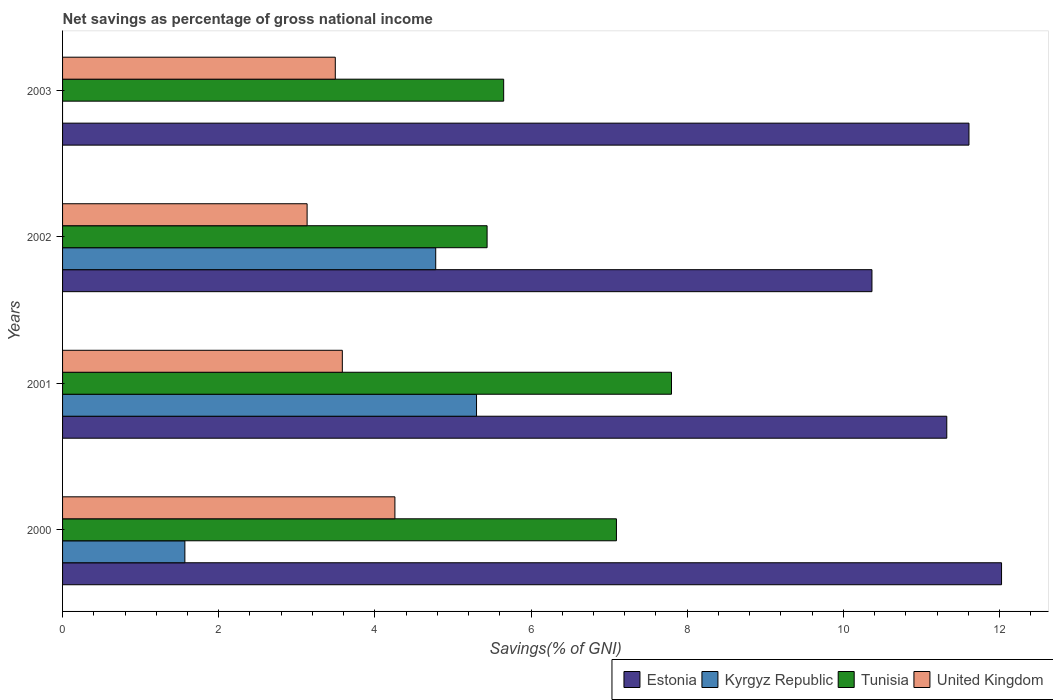How many groups of bars are there?
Give a very brief answer. 4. Are the number of bars on each tick of the Y-axis equal?
Provide a succinct answer. No. How many bars are there on the 4th tick from the top?
Provide a succinct answer. 4. What is the total savings in Estonia in 2000?
Provide a short and direct response. 12.03. Across all years, what is the maximum total savings in Tunisia?
Give a very brief answer. 7.8. Across all years, what is the minimum total savings in United Kingdom?
Provide a succinct answer. 3.13. What is the total total savings in Tunisia in the graph?
Make the answer very short. 25.98. What is the difference between the total savings in United Kingdom in 2001 and that in 2002?
Provide a short and direct response. 0.45. What is the difference between the total savings in United Kingdom in 2003 and the total savings in Kyrgyz Republic in 2002?
Offer a terse response. -1.29. What is the average total savings in United Kingdom per year?
Offer a very short reply. 3.62. In the year 2003, what is the difference between the total savings in Tunisia and total savings in United Kingdom?
Offer a very short reply. 2.16. What is the ratio of the total savings in Kyrgyz Republic in 2001 to that in 2002?
Your response must be concise. 1.11. What is the difference between the highest and the second highest total savings in Kyrgyz Republic?
Offer a very short reply. 0.52. What is the difference between the highest and the lowest total savings in Estonia?
Your answer should be very brief. 1.66. Is it the case that in every year, the sum of the total savings in Tunisia and total savings in United Kingdom is greater than the sum of total savings in Kyrgyz Republic and total savings in Estonia?
Give a very brief answer. Yes. How many bars are there?
Offer a terse response. 15. Are all the bars in the graph horizontal?
Your answer should be compact. Yes. How many years are there in the graph?
Keep it short and to the point. 4. What is the difference between two consecutive major ticks on the X-axis?
Make the answer very short. 2. Does the graph contain any zero values?
Keep it short and to the point. Yes. Does the graph contain grids?
Keep it short and to the point. No. What is the title of the graph?
Offer a terse response. Net savings as percentage of gross national income. Does "Bhutan" appear as one of the legend labels in the graph?
Provide a short and direct response. No. What is the label or title of the X-axis?
Make the answer very short. Savings(% of GNI). What is the label or title of the Y-axis?
Keep it short and to the point. Years. What is the Savings(% of GNI) of Estonia in 2000?
Provide a short and direct response. 12.03. What is the Savings(% of GNI) of Kyrgyz Republic in 2000?
Ensure brevity in your answer.  1.57. What is the Savings(% of GNI) of Tunisia in 2000?
Provide a short and direct response. 7.09. What is the Savings(% of GNI) of United Kingdom in 2000?
Your response must be concise. 4.26. What is the Savings(% of GNI) in Estonia in 2001?
Your answer should be compact. 11.33. What is the Savings(% of GNI) of Kyrgyz Republic in 2001?
Provide a succinct answer. 5.3. What is the Savings(% of GNI) in Tunisia in 2001?
Give a very brief answer. 7.8. What is the Savings(% of GNI) in United Kingdom in 2001?
Your answer should be compact. 3.58. What is the Savings(% of GNI) of Estonia in 2002?
Your answer should be very brief. 10.37. What is the Savings(% of GNI) in Kyrgyz Republic in 2002?
Offer a terse response. 4.78. What is the Savings(% of GNI) in Tunisia in 2002?
Your response must be concise. 5.44. What is the Savings(% of GNI) in United Kingdom in 2002?
Your answer should be compact. 3.13. What is the Savings(% of GNI) in Estonia in 2003?
Give a very brief answer. 11.61. What is the Savings(% of GNI) in Tunisia in 2003?
Offer a very short reply. 5.65. What is the Savings(% of GNI) in United Kingdom in 2003?
Your answer should be very brief. 3.49. Across all years, what is the maximum Savings(% of GNI) of Estonia?
Offer a very short reply. 12.03. Across all years, what is the maximum Savings(% of GNI) of Kyrgyz Republic?
Make the answer very short. 5.3. Across all years, what is the maximum Savings(% of GNI) of Tunisia?
Give a very brief answer. 7.8. Across all years, what is the maximum Savings(% of GNI) of United Kingdom?
Make the answer very short. 4.26. Across all years, what is the minimum Savings(% of GNI) in Estonia?
Give a very brief answer. 10.37. Across all years, what is the minimum Savings(% of GNI) in Tunisia?
Your answer should be very brief. 5.44. Across all years, what is the minimum Savings(% of GNI) of United Kingdom?
Your response must be concise. 3.13. What is the total Savings(% of GNI) of Estonia in the graph?
Your response must be concise. 45.33. What is the total Savings(% of GNI) in Kyrgyz Republic in the graph?
Your response must be concise. 11.65. What is the total Savings(% of GNI) of Tunisia in the graph?
Make the answer very short. 25.98. What is the total Savings(% of GNI) in United Kingdom in the graph?
Provide a succinct answer. 14.47. What is the difference between the Savings(% of GNI) in Estonia in 2000 and that in 2001?
Make the answer very short. 0.7. What is the difference between the Savings(% of GNI) of Kyrgyz Republic in 2000 and that in 2001?
Provide a succinct answer. -3.74. What is the difference between the Savings(% of GNI) of Tunisia in 2000 and that in 2001?
Keep it short and to the point. -0.71. What is the difference between the Savings(% of GNI) in United Kingdom in 2000 and that in 2001?
Ensure brevity in your answer.  0.67. What is the difference between the Savings(% of GNI) of Estonia in 2000 and that in 2002?
Keep it short and to the point. 1.66. What is the difference between the Savings(% of GNI) of Kyrgyz Republic in 2000 and that in 2002?
Offer a terse response. -3.21. What is the difference between the Savings(% of GNI) in Tunisia in 2000 and that in 2002?
Your answer should be very brief. 1.66. What is the difference between the Savings(% of GNI) in United Kingdom in 2000 and that in 2002?
Keep it short and to the point. 1.12. What is the difference between the Savings(% of GNI) of Estonia in 2000 and that in 2003?
Your answer should be compact. 0.42. What is the difference between the Savings(% of GNI) of Tunisia in 2000 and that in 2003?
Your answer should be compact. 1.44. What is the difference between the Savings(% of GNI) of United Kingdom in 2000 and that in 2003?
Give a very brief answer. 0.76. What is the difference between the Savings(% of GNI) in Estonia in 2001 and that in 2002?
Your answer should be very brief. 0.96. What is the difference between the Savings(% of GNI) of Kyrgyz Republic in 2001 and that in 2002?
Your response must be concise. 0.52. What is the difference between the Savings(% of GNI) in Tunisia in 2001 and that in 2002?
Your answer should be very brief. 2.36. What is the difference between the Savings(% of GNI) of United Kingdom in 2001 and that in 2002?
Your answer should be very brief. 0.45. What is the difference between the Savings(% of GNI) in Estonia in 2001 and that in 2003?
Your response must be concise. -0.28. What is the difference between the Savings(% of GNI) in Tunisia in 2001 and that in 2003?
Provide a short and direct response. 2.15. What is the difference between the Savings(% of GNI) in United Kingdom in 2001 and that in 2003?
Your answer should be very brief. 0.09. What is the difference between the Savings(% of GNI) of Estonia in 2002 and that in 2003?
Provide a succinct answer. -1.24. What is the difference between the Savings(% of GNI) of Tunisia in 2002 and that in 2003?
Keep it short and to the point. -0.21. What is the difference between the Savings(% of GNI) in United Kingdom in 2002 and that in 2003?
Give a very brief answer. -0.36. What is the difference between the Savings(% of GNI) of Estonia in 2000 and the Savings(% of GNI) of Kyrgyz Republic in 2001?
Your answer should be compact. 6.72. What is the difference between the Savings(% of GNI) of Estonia in 2000 and the Savings(% of GNI) of Tunisia in 2001?
Provide a succinct answer. 4.23. What is the difference between the Savings(% of GNI) in Estonia in 2000 and the Savings(% of GNI) in United Kingdom in 2001?
Your response must be concise. 8.44. What is the difference between the Savings(% of GNI) in Kyrgyz Republic in 2000 and the Savings(% of GNI) in Tunisia in 2001?
Provide a succinct answer. -6.23. What is the difference between the Savings(% of GNI) in Kyrgyz Republic in 2000 and the Savings(% of GNI) in United Kingdom in 2001?
Your answer should be compact. -2.02. What is the difference between the Savings(% of GNI) of Tunisia in 2000 and the Savings(% of GNI) of United Kingdom in 2001?
Offer a very short reply. 3.51. What is the difference between the Savings(% of GNI) in Estonia in 2000 and the Savings(% of GNI) in Kyrgyz Republic in 2002?
Ensure brevity in your answer.  7.25. What is the difference between the Savings(% of GNI) of Estonia in 2000 and the Savings(% of GNI) of Tunisia in 2002?
Offer a very short reply. 6.59. What is the difference between the Savings(% of GNI) in Estonia in 2000 and the Savings(% of GNI) in United Kingdom in 2002?
Keep it short and to the point. 8.89. What is the difference between the Savings(% of GNI) in Kyrgyz Republic in 2000 and the Savings(% of GNI) in Tunisia in 2002?
Make the answer very short. -3.87. What is the difference between the Savings(% of GNI) of Kyrgyz Republic in 2000 and the Savings(% of GNI) of United Kingdom in 2002?
Offer a very short reply. -1.57. What is the difference between the Savings(% of GNI) of Tunisia in 2000 and the Savings(% of GNI) of United Kingdom in 2002?
Offer a terse response. 3.96. What is the difference between the Savings(% of GNI) in Estonia in 2000 and the Savings(% of GNI) in Tunisia in 2003?
Your response must be concise. 6.38. What is the difference between the Savings(% of GNI) in Estonia in 2000 and the Savings(% of GNI) in United Kingdom in 2003?
Ensure brevity in your answer.  8.53. What is the difference between the Savings(% of GNI) in Kyrgyz Republic in 2000 and the Savings(% of GNI) in Tunisia in 2003?
Make the answer very short. -4.08. What is the difference between the Savings(% of GNI) of Kyrgyz Republic in 2000 and the Savings(% of GNI) of United Kingdom in 2003?
Give a very brief answer. -1.93. What is the difference between the Savings(% of GNI) in Tunisia in 2000 and the Savings(% of GNI) in United Kingdom in 2003?
Keep it short and to the point. 3.6. What is the difference between the Savings(% of GNI) of Estonia in 2001 and the Savings(% of GNI) of Kyrgyz Republic in 2002?
Give a very brief answer. 6.55. What is the difference between the Savings(% of GNI) in Estonia in 2001 and the Savings(% of GNI) in Tunisia in 2002?
Your answer should be compact. 5.89. What is the difference between the Savings(% of GNI) in Estonia in 2001 and the Savings(% of GNI) in United Kingdom in 2002?
Your answer should be compact. 8.19. What is the difference between the Savings(% of GNI) of Kyrgyz Republic in 2001 and the Savings(% of GNI) of Tunisia in 2002?
Keep it short and to the point. -0.14. What is the difference between the Savings(% of GNI) of Kyrgyz Republic in 2001 and the Savings(% of GNI) of United Kingdom in 2002?
Keep it short and to the point. 2.17. What is the difference between the Savings(% of GNI) of Tunisia in 2001 and the Savings(% of GNI) of United Kingdom in 2002?
Keep it short and to the point. 4.67. What is the difference between the Savings(% of GNI) in Estonia in 2001 and the Savings(% of GNI) in Tunisia in 2003?
Ensure brevity in your answer.  5.68. What is the difference between the Savings(% of GNI) in Estonia in 2001 and the Savings(% of GNI) in United Kingdom in 2003?
Your answer should be compact. 7.83. What is the difference between the Savings(% of GNI) of Kyrgyz Republic in 2001 and the Savings(% of GNI) of Tunisia in 2003?
Keep it short and to the point. -0.35. What is the difference between the Savings(% of GNI) of Kyrgyz Republic in 2001 and the Savings(% of GNI) of United Kingdom in 2003?
Offer a terse response. 1.81. What is the difference between the Savings(% of GNI) of Tunisia in 2001 and the Savings(% of GNI) of United Kingdom in 2003?
Give a very brief answer. 4.31. What is the difference between the Savings(% of GNI) of Estonia in 2002 and the Savings(% of GNI) of Tunisia in 2003?
Provide a short and direct response. 4.72. What is the difference between the Savings(% of GNI) in Estonia in 2002 and the Savings(% of GNI) in United Kingdom in 2003?
Offer a very short reply. 6.87. What is the difference between the Savings(% of GNI) of Kyrgyz Republic in 2002 and the Savings(% of GNI) of Tunisia in 2003?
Provide a succinct answer. -0.87. What is the difference between the Savings(% of GNI) in Kyrgyz Republic in 2002 and the Savings(% of GNI) in United Kingdom in 2003?
Give a very brief answer. 1.29. What is the difference between the Savings(% of GNI) of Tunisia in 2002 and the Savings(% of GNI) of United Kingdom in 2003?
Your answer should be very brief. 1.94. What is the average Savings(% of GNI) in Estonia per year?
Give a very brief answer. 11.33. What is the average Savings(% of GNI) of Kyrgyz Republic per year?
Offer a terse response. 2.91. What is the average Savings(% of GNI) of Tunisia per year?
Offer a terse response. 6.5. What is the average Savings(% of GNI) of United Kingdom per year?
Give a very brief answer. 3.62. In the year 2000, what is the difference between the Savings(% of GNI) of Estonia and Savings(% of GNI) of Kyrgyz Republic?
Keep it short and to the point. 10.46. In the year 2000, what is the difference between the Savings(% of GNI) of Estonia and Savings(% of GNI) of Tunisia?
Keep it short and to the point. 4.93. In the year 2000, what is the difference between the Savings(% of GNI) in Estonia and Savings(% of GNI) in United Kingdom?
Provide a short and direct response. 7.77. In the year 2000, what is the difference between the Savings(% of GNI) of Kyrgyz Republic and Savings(% of GNI) of Tunisia?
Your answer should be compact. -5.53. In the year 2000, what is the difference between the Savings(% of GNI) in Kyrgyz Republic and Savings(% of GNI) in United Kingdom?
Make the answer very short. -2.69. In the year 2000, what is the difference between the Savings(% of GNI) of Tunisia and Savings(% of GNI) of United Kingdom?
Provide a short and direct response. 2.84. In the year 2001, what is the difference between the Savings(% of GNI) in Estonia and Savings(% of GNI) in Kyrgyz Republic?
Offer a very short reply. 6.02. In the year 2001, what is the difference between the Savings(% of GNI) in Estonia and Savings(% of GNI) in Tunisia?
Give a very brief answer. 3.53. In the year 2001, what is the difference between the Savings(% of GNI) in Estonia and Savings(% of GNI) in United Kingdom?
Keep it short and to the point. 7.74. In the year 2001, what is the difference between the Savings(% of GNI) in Kyrgyz Republic and Savings(% of GNI) in Tunisia?
Provide a succinct answer. -2.5. In the year 2001, what is the difference between the Savings(% of GNI) in Kyrgyz Republic and Savings(% of GNI) in United Kingdom?
Provide a succinct answer. 1.72. In the year 2001, what is the difference between the Savings(% of GNI) in Tunisia and Savings(% of GNI) in United Kingdom?
Offer a very short reply. 4.22. In the year 2002, what is the difference between the Savings(% of GNI) in Estonia and Savings(% of GNI) in Kyrgyz Republic?
Ensure brevity in your answer.  5.59. In the year 2002, what is the difference between the Savings(% of GNI) in Estonia and Savings(% of GNI) in Tunisia?
Ensure brevity in your answer.  4.93. In the year 2002, what is the difference between the Savings(% of GNI) of Estonia and Savings(% of GNI) of United Kingdom?
Give a very brief answer. 7.23. In the year 2002, what is the difference between the Savings(% of GNI) of Kyrgyz Republic and Savings(% of GNI) of Tunisia?
Your response must be concise. -0.66. In the year 2002, what is the difference between the Savings(% of GNI) of Kyrgyz Republic and Savings(% of GNI) of United Kingdom?
Keep it short and to the point. 1.65. In the year 2002, what is the difference between the Savings(% of GNI) in Tunisia and Savings(% of GNI) in United Kingdom?
Offer a very short reply. 2.31. In the year 2003, what is the difference between the Savings(% of GNI) of Estonia and Savings(% of GNI) of Tunisia?
Offer a terse response. 5.96. In the year 2003, what is the difference between the Savings(% of GNI) in Estonia and Savings(% of GNI) in United Kingdom?
Offer a terse response. 8.12. In the year 2003, what is the difference between the Savings(% of GNI) in Tunisia and Savings(% of GNI) in United Kingdom?
Offer a very short reply. 2.16. What is the ratio of the Savings(% of GNI) of Estonia in 2000 to that in 2001?
Your answer should be compact. 1.06. What is the ratio of the Savings(% of GNI) of Kyrgyz Republic in 2000 to that in 2001?
Offer a terse response. 0.3. What is the ratio of the Savings(% of GNI) of Tunisia in 2000 to that in 2001?
Give a very brief answer. 0.91. What is the ratio of the Savings(% of GNI) of United Kingdom in 2000 to that in 2001?
Keep it short and to the point. 1.19. What is the ratio of the Savings(% of GNI) of Estonia in 2000 to that in 2002?
Your answer should be very brief. 1.16. What is the ratio of the Savings(% of GNI) in Kyrgyz Republic in 2000 to that in 2002?
Offer a terse response. 0.33. What is the ratio of the Savings(% of GNI) of Tunisia in 2000 to that in 2002?
Provide a succinct answer. 1.3. What is the ratio of the Savings(% of GNI) of United Kingdom in 2000 to that in 2002?
Keep it short and to the point. 1.36. What is the ratio of the Savings(% of GNI) of Estonia in 2000 to that in 2003?
Keep it short and to the point. 1.04. What is the ratio of the Savings(% of GNI) of Tunisia in 2000 to that in 2003?
Your answer should be very brief. 1.26. What is the ratio of the Savings(% of GNI) of United Kingdom in 2000 to that in 2003?
Make the answer very short. 1.22. What is the ratio of the Savings(% of GNI) in Estonia in 2001 to that in 2002?
Offer a very short reply. 1.09. What is the ratio of the Savings(% of GNI) in Kyrgyz Republic in 2001 to that in 2002?
Give a very brief answer. 1.11. What is the ratio of the Savings(% of GNI) in Tunisia in 2001 to that in 2002?
Give a very brief answer. 1.43. What is the ratio of the Savings(% of GNI) of United Kingdom in 2001 to that in 2002?
Provide a short and direct response. 1.14. What is the ratio of the Savings(% of GNI) of Estonia in 2001 to that in 2003?
Your response must be concise. 0.98. What is the ratio of the Savings(% of GNI) of Tunisia in 2001 to that in 2003?
Offer a terse response. 1.38. What is the ratio of the Savings(% of GNI) of United Kingdom in 2001 to that in 2003?
Offer a terse response. 1.03. What is the ratio of the Savings(% of GNI) in Estonia in 2002 to that in 2003?
Ensure brevity in your answer.  0.89. What is the ratio of the Savings(% of GNI) in Tunisia in 2002 to that in 2003?
Make the answer very short. 0.96. What is the ratio of the Savings(% of GNI) in United Kingdom in 2002 to that in 2003?
Keep it short and to the point. 0.9. What is the difference between the highest and the second highest Savings(% of GNI) of Estonia?
Give a very brief answer. 0.42. What is the difference between the highest and the second highest Savings(% of GNI) of Kyrgyz Republic?
Your response must be concise. 0.52. What is the difference between the highest and the second highest Savings(% of GNI) of Tunisia?
Your answer should be compact. 0.71. What is the difference between the highest and the second highest Savings(% of GNI) in United Kingdom?
Offer a very short reply. 0.67. What is the difference between the highest and the lowest Savings(% of GNI) of Estonia?
Offer a terse response. 1.66. What is the difference between the highest and the lowest Savings(% of GNI) of Kyrgyz Republic?
Provide a succinct answer. 5.3. What is the difference between the highest and the lowest Savings(% of GNI) of Tunisia?
Ensure brevity in your answer.  2.36. What is the difference between the highest and the lowest Savings(% of GNI) in United Kingdom?
Keep it short and to the point. 1.12. 